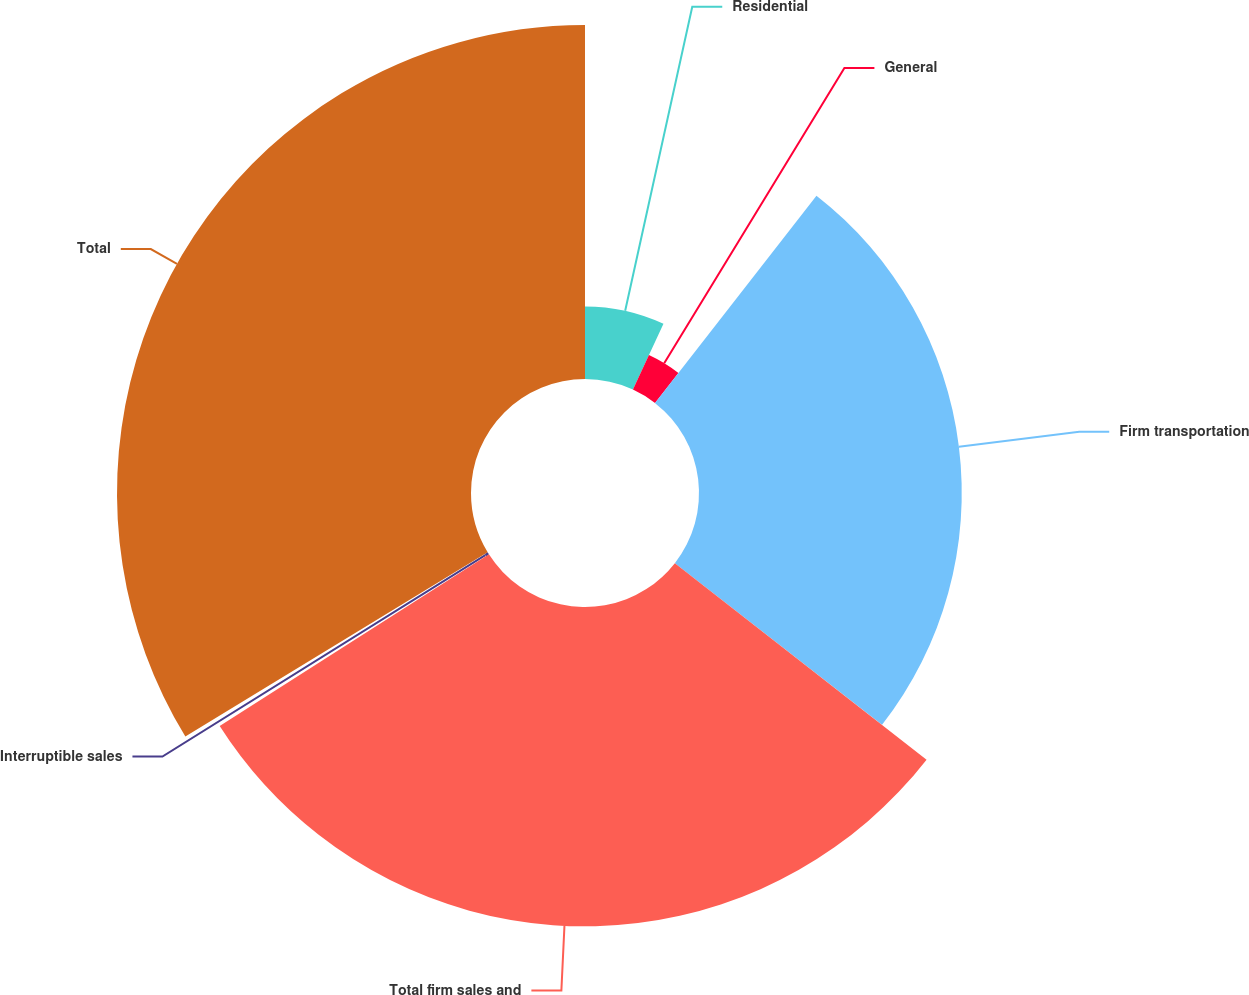<chart> <loc_0><loc_0><loc_500><loc_500><pie_chart><fcel>Residential<fcel>General<fcel>Firm transportation<fcel>Total firm sales and<fcel>Interruptible sales<fcel>Total<nl><fcel>6.91%<fcel>3.62%<fcel>25.02%<fcel>30.41%<fcel>0.33%<fcel>33.71%<nl></chart> 